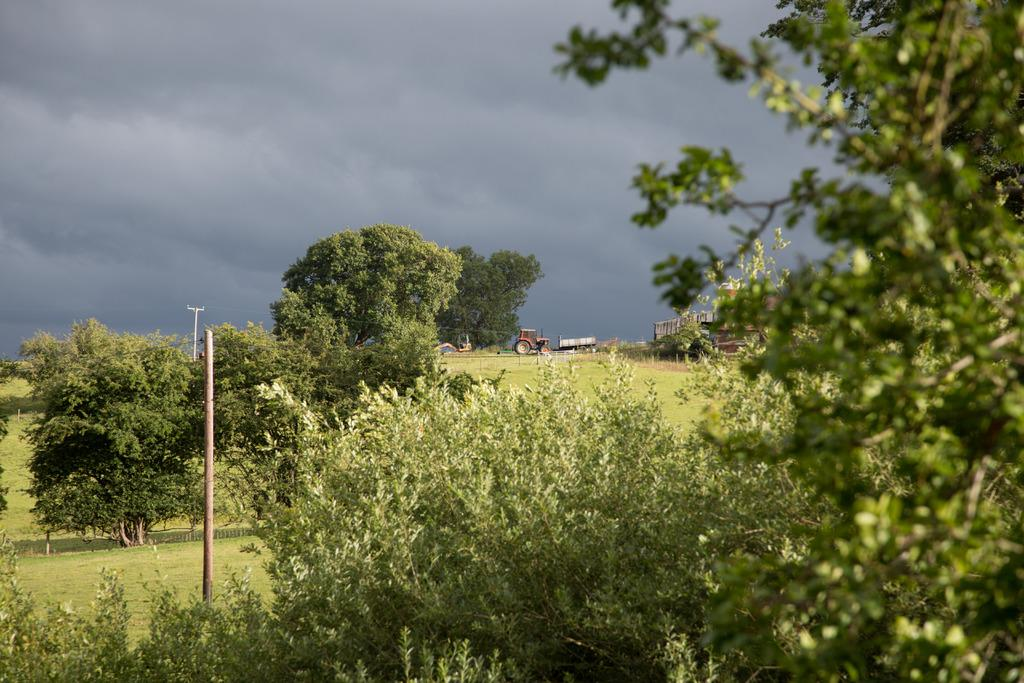What type of natural elements can be seen in the image? There are trees in the image. What man-made objects are present in the image? There are vehicles, sheds, and poles in the image. What is visible at the bottom of the image? There is a ground visible at the bottom of the image. What is visible at the top of the image? There is sky visible at the top of the image. How does the organization of the trees and vehicles in the image contribute to the quiet atmosphere? The image does not convey any information about the atmosphere or the organization of the trees and vehicles. Additionally, there is no mention of an organization in the image. 